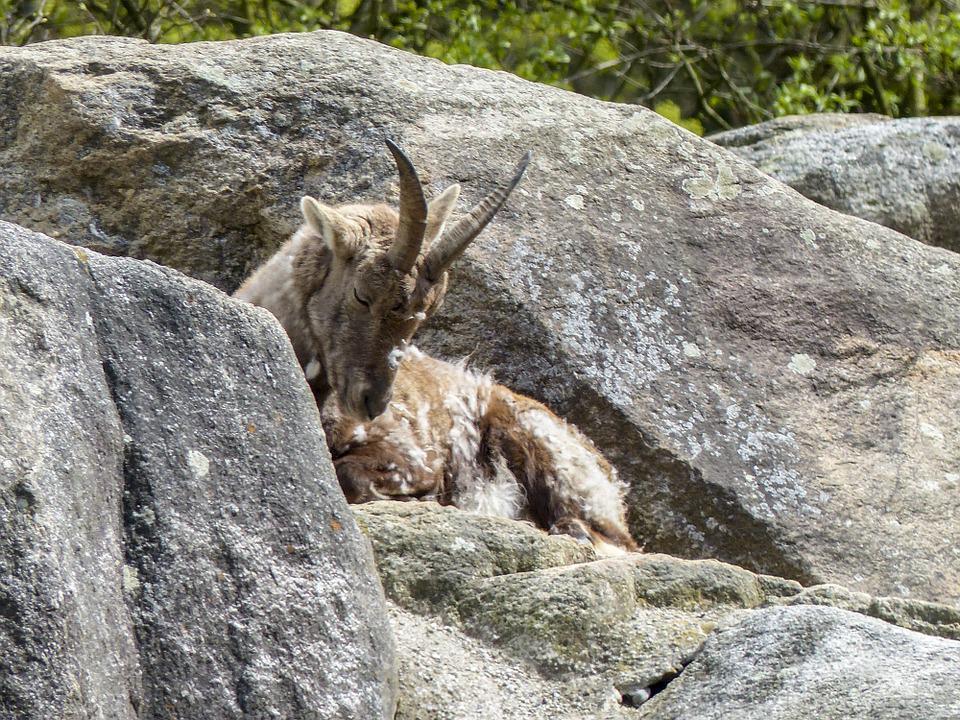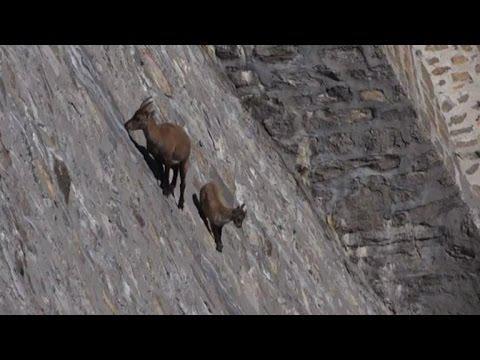The first image is the image on the left, the second image is the image on the right. Assess this claim about the two images: "One image shows multiple antelope on a sheer rock wall bare of any foliage.". Correct or not? Answer yes or no. Yes. 